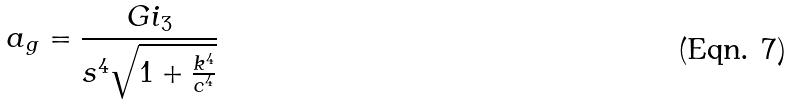Convert formula to latex. <formula><loc_0><loc_0><loc_500><loc_500>a _ { g } = \frac { G i _ { 3 } } { s ^ { 4 } \sqrt { 1 + \frac { k ^ { 4 } } { c ^ { 4 } } } }</formula> 